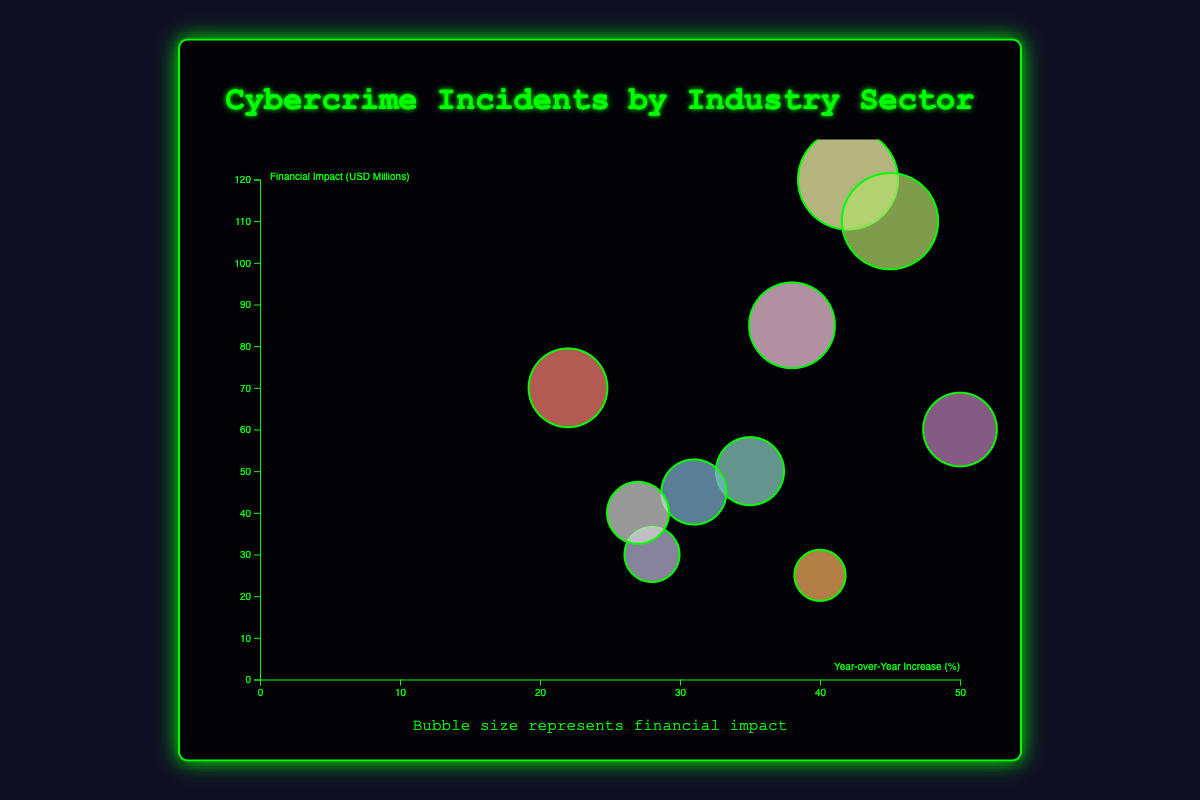What is the industry sector with the highest year-over-year increase in cybercrime incidents? This can be seen by identifying the industry with the highest value on the x-axis. The Hospitality sector shows the highest value at 50%.
Answer: Hospitality Which sector has the largest financial impact due to cybercrime? Look for the largest bubble based on size in the plot. The Financial Services sector has a bubble representing $120 million in financial impact, which is the largest.
Answer: Financial Services Which industry has a year-over-year increase of above 40% but a financial impact below $50 million? The x-axis denotes the year-over-year increase, and the y-axis denotes the financial impact. Look for bubbles with x > 40% and y < $50 million. The Education sector fits these criteria.
Answer: Education What is the total financial impact for Healthcare and Technology sectors combined? Add the financial impacts of these two sectors: Healthcare ($50 million) and Technology ($85 million). The total is $50M + $85M = $135M.
Answer: $135 million Which sectors have a year-over-year increase between 25% and 35% and a financial impact of more than $40 million? Check bubbles between 25% and 35% on the x-axis and more than $40 million on the y-axis. These include Healthcare and Energy.
Answer: Healthcare and Energy Compare the financial impacts of Government and Technology sectors. Which has the higher impact? Check the y-axis values for Government ($110 million) and Technology ($85 million). Government has a higher impact.
Answer: Government What is the median financial impact of all sectors listed? List all financial impacts: $50M, $120M, $30M, $70M, $45M, $25M, $110M, $85M, $40M, $60M. Sort to find the median value, which is the middle number. The sorted list is $25M, $30M, $40M, $45M, $50M, $60M, $70M, $85M, $110M, $120M. The middle value between $50M and $60M is ($50M + $60M) / 2 = $55M.
Answer: $55 million Identify the industry with the smallest year-over-year increase and state the percentage. Find the smallest x-axis value. The Manufacturing sector has the smallest increase at 22%.
Answer: Manufacturing Which sector has a financial impact closest to $65 million? Observe the y-axis values to find the closest to $65 million. The Manufacturing sector, with $70 million, is closest.
Answer: Manufacturing 